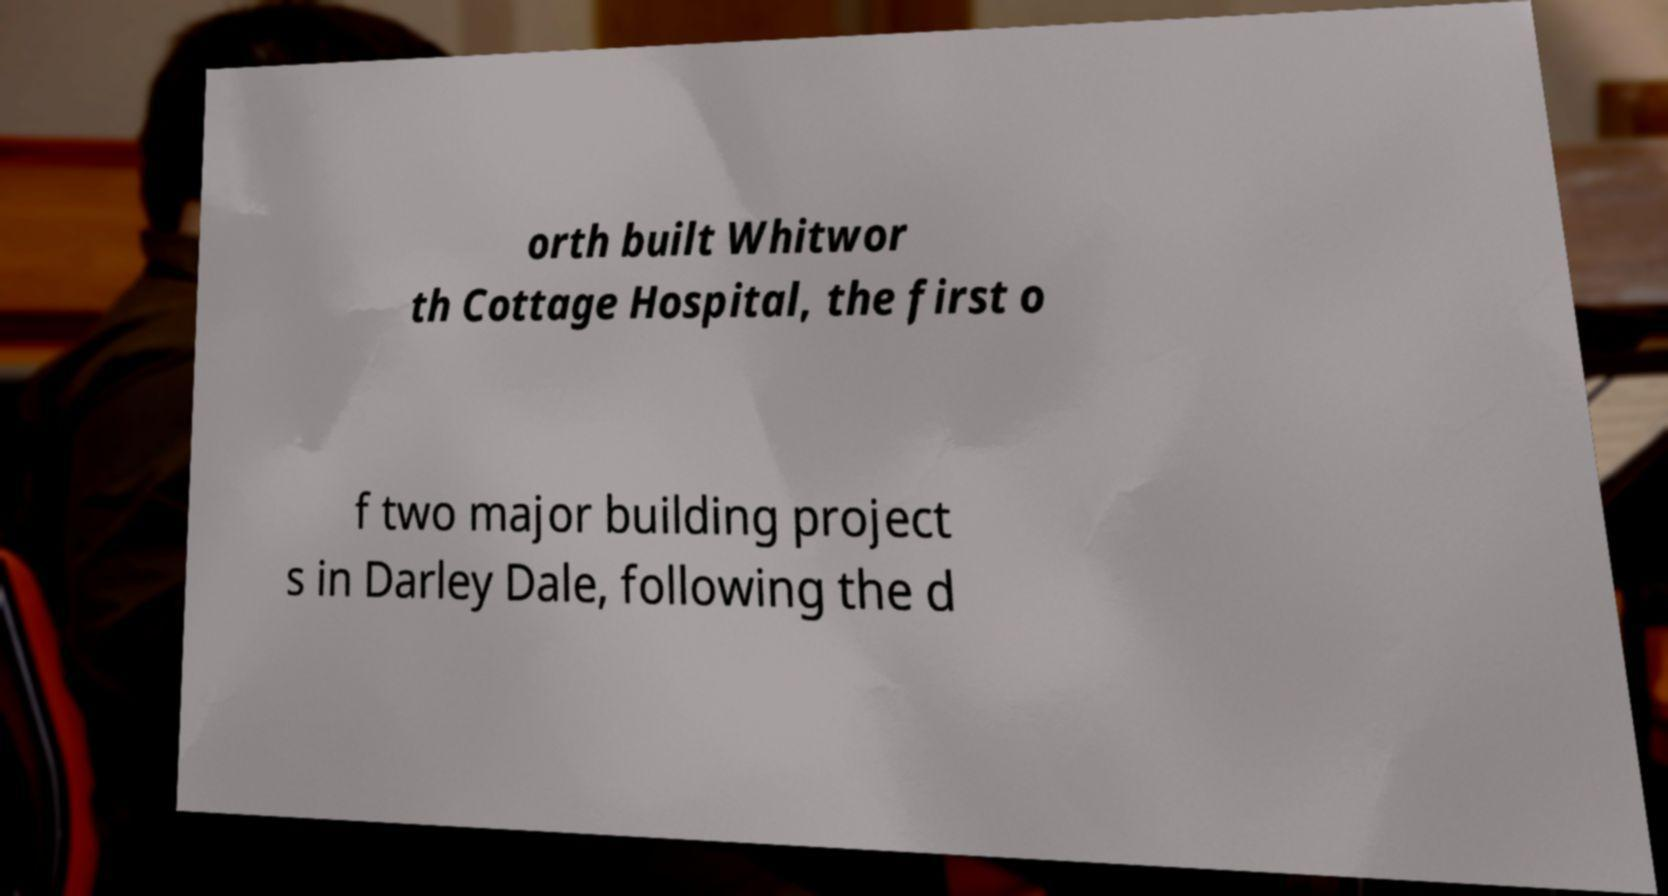Can you read and provide the text displayed in the image?This photo seems to have some interesting text. Can you extract and type it out for me? orth built Whitwor th Cottage Hospital, the first o f two major building project s in Darley Dale, following the d 